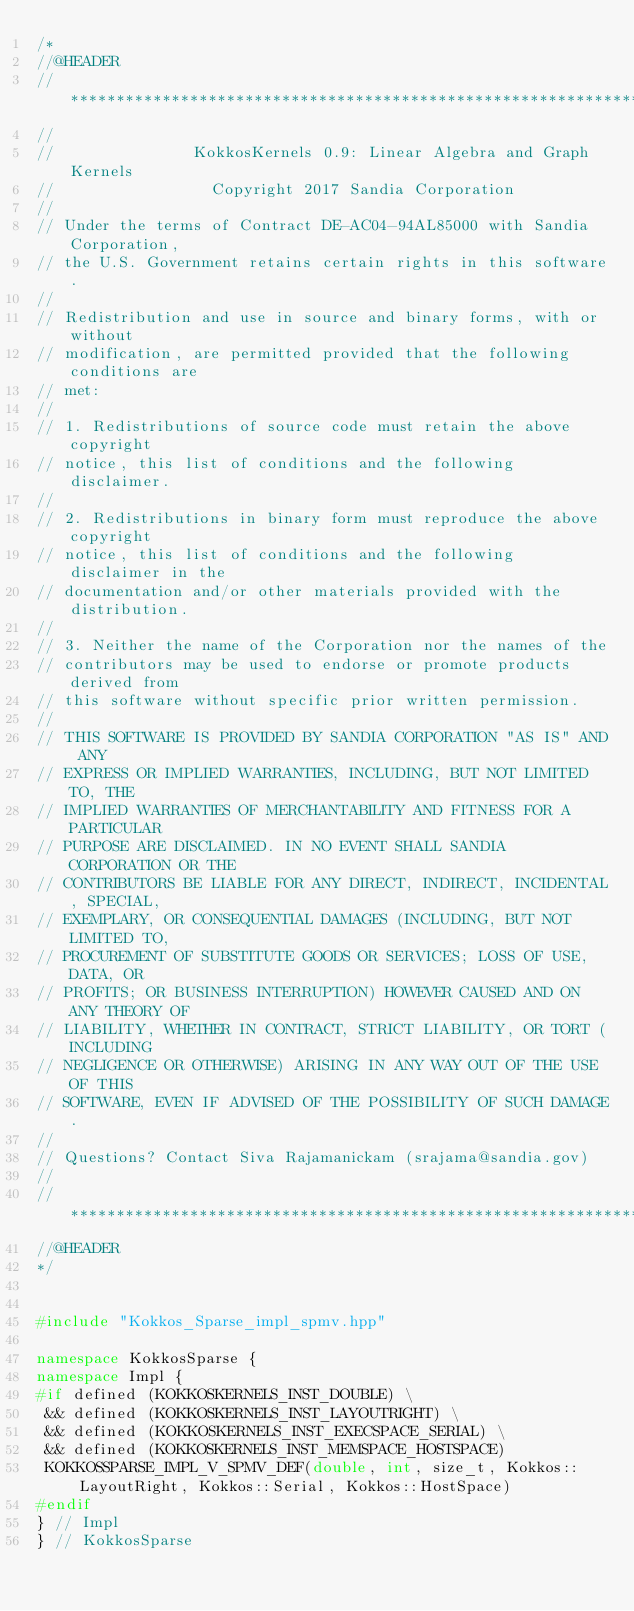Convert code to text. <code><loc_0><loc_0><loc_500><loc_500><_C++_>/*
//@HEADER
// ************************************************************************
//
//               KokkosKernels 0.9: Linear Algebra and Graph Kernels
//                 Copyright 2017 Sandia Corporation
//
// Under the terms of Contract DE-AC04-94AL85000 with Sandia Corporation,
// the U.S. Government retains certain rights in this software.
//
// Redistribution and use in source and binary forms, with or without
// modification, are permitted provided that the following conditions are
// met:
//
// 1. Redistributions of source code must retain the above copyright
// notice, this list of conditions and the following disclaimer.
//
// 2. Redistributions in binary form must reproduce the above copyright
// notice, this list of conditions and the following disclaimer in the
// documentation and/or other materials provided with the distribution.
//
// 3. Neither the name of the Corporation nor the names of the
// contributors may be used to endorse or promote products derived from
// this software without specific prior written permission.
//
// THIS SOFTWARE IS PROVIDED BY SANDIA CORPORATION "AS IS" AND ANY
// EXPRESS OR IMPLIED WARRANTIES, INCLUDING, BUT NOT LIMITED TO, THE
// IMPLIED WARRANTIES OF MERCHANTABILITY AND FITNESS FOR A PARTICULAR
// PURPOSE ARE DISCLAIMED. IN NO EVENT SHALL SANDIA CORPORATION OR THE
// CONTRIBUTORS BE LIABLE FOR ANY DIRECT, INDIRECT, INCIDENTAL, SPECIAL,
// EXEMPLARY, OR CONSEQUENTIAL DAMAGES (INCLUDING, BUT NOT LIMITED TO,
// PROCUREMENT OF SUBSTITUTE GOODS OR SERVICES; LOSS OF USE, DATA, OR
// PROFITS; OR BUSINESS INTERRUPTION) HOWEVER CAUSED AND ON ANY THEORY OF
// LIABILITY, WHETHER IN CONTRACT, STRICT LIABILITY, OR TORT (INCLUDING
// NEGLIGENCE OR OTHERWISE) ARISING IN ANY WAY OUT OF THE USE OF THIS
// SOFTWARE, EVEN IF ADVISED OF THE POSSIBILITY OF SUCH DAMAGE.
//
// Questions? Contact Siva Rajamanickam (srajama@sandia.gov)
//
// ************************************************************************
//@HEADER
*/


#include "Kokkos_Sparse_impl_spmv.hpp"

namespace KokkosSparse {
namespace Impl {
#if defined (KOKKOSKERNELS_INST_DOUBLE) \
 && defined (KOKKOSKERNELS_INST_LAYOUTRIGHT) \
 && defined (KOKKOSKERNELS_INST_EXECSPACE_SERIAL) \
 && defined (KOKKOSKERNELS_INST_MEMSPACE_HOSTSPACE)
 KOKKOSSPARSE_IMPL_V_SPMV_DEF(double, int, size_t, Kokkos::LayoutRight, Kokkos::Serial, Kokkos::HostSpace)
#endif
} // Impl
} // KokkosSparse
</code> 